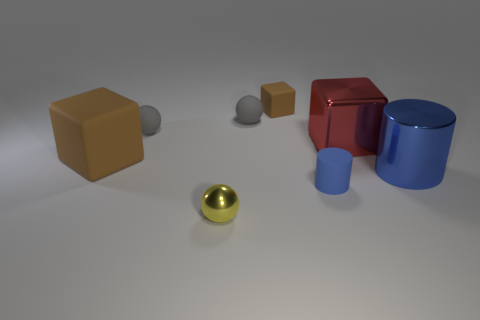Subtract all purple cylinders. How many gray balls are left? 2 Subtract all small rubber spheres. How many spheres are left? 1 Add 1 large cyan matte cylinders. How many objects exist? 9 Subtract 1 cubes. How many cubes are left? 2 Subtract all blue blocks. Subtract all red cylinders. How many blocks are left? 3 Subtract all cubes. How many objects are left? 5 Subtract 0 purple blocks. How many objects are left? 8 Subtract all shiny things. Subtract all tiny shiny cylinders. How many objects are left? 5 Add 4 red things. How many red things are left? 5 Add 6 green matte balls. How many green matte balls exist? 6 